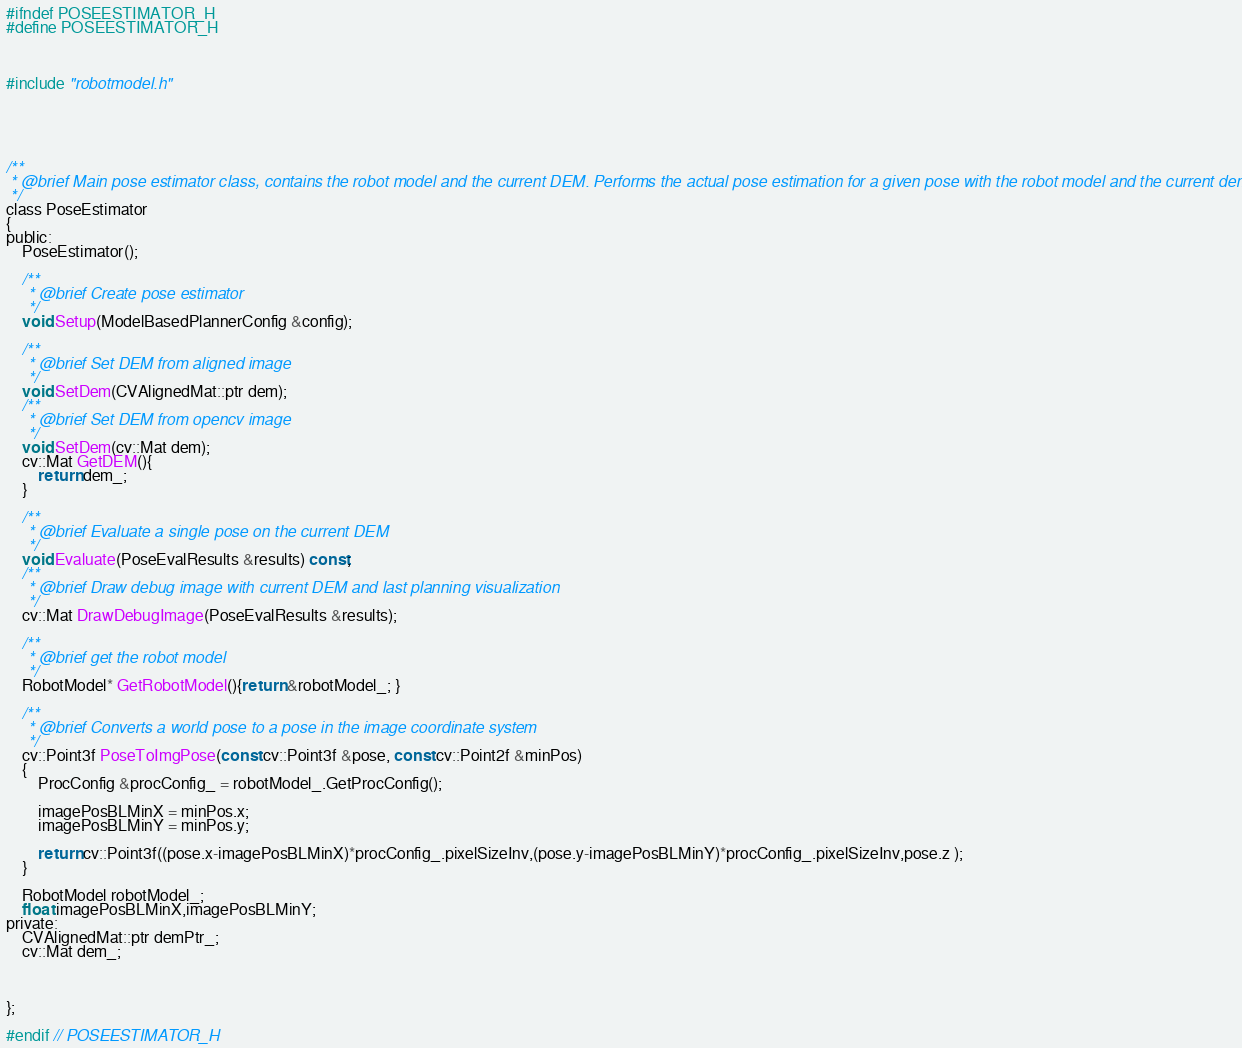Convert code to text. <code><loc_0><loc_0><loc_500><loc_500><_C_>#ifndef POSEESTIMATOR_H
#define POSEESTIMATOR_H



#include "robotmodel.h"





/**
 * @brief Main pose estimator class, contains the robot model and the current DEM. Performs the actual pose estimation for a given pose with the robot model and the current dem
 */
class PoseEstimator
{
public:
    PoseEstimator();

    /**
     * @brief Create pose estimator
     */
    void Setup(ModelBasedPlannerConfig &config);

    /**
     * @brief Set DEM from aligned image
     */
    void SetDem(CVAlignedMat::ptr dem);
    /**
     * @brief Set DEM from opencv image
     */
    void SetDem(cv::Mat dem);
    cv::Mat GetDEM(){
        return dem_;
    }

    /**
     * @brief Evaluate a single pose on the current DEM
     */
    void Evaluate(PoseEvalResults &results) const;
    /**
     * @brief Draw debug image with current DEM and last planning visualization
     */
    cv::Mat DrawDebugImage(PoseEvalResults &results);

    /**
     * @brief get the robot model
     */
    RobotModel* GetRobotModel(){return &robotModel_; }

    /**
     * @brief Converts a world pose to a pose in the image coordinate system
     */
    cv::Point3f PoseToImgPose(const cv::Point3f &pose, const cv::Point2f &minPos)
    {
        ProcConfig &procConfig_ = robotModel_.GetProcConfig();

        imagePosBLMinX = minPos.x;
        imagePosBLMinY = minPos.y;

        return cv::Point3f((pose.x-imagePosBLMinX)*procConfig_.pixelSizeInv,(pose.y-imagePosBLMinY)*procConfig_.pixelSizeInv,pose.z );
    }

    RobotModel robotModel_;
    float imagePosBLMinX,imagePosBLMinY;
private:
    CVAlignedMat::ptr demPtr_;
    cv::Mat dem_;



};

#endif // POSEESTIMATOR_H
</code> 